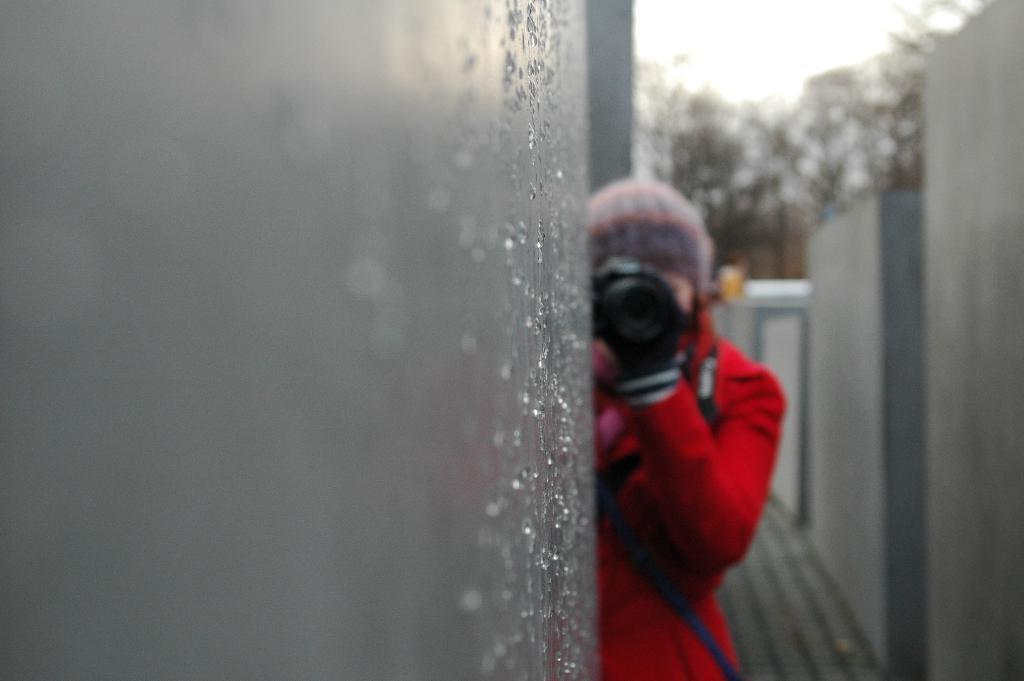How would you summarize this image in a sentence or two? In this picture there is a woman who is wearing cap, red jacket, gloves and bag. She is holding a camera near to the wall. On the wall we can see water drops. On the background we can see many trees. On the top there is a sky. 